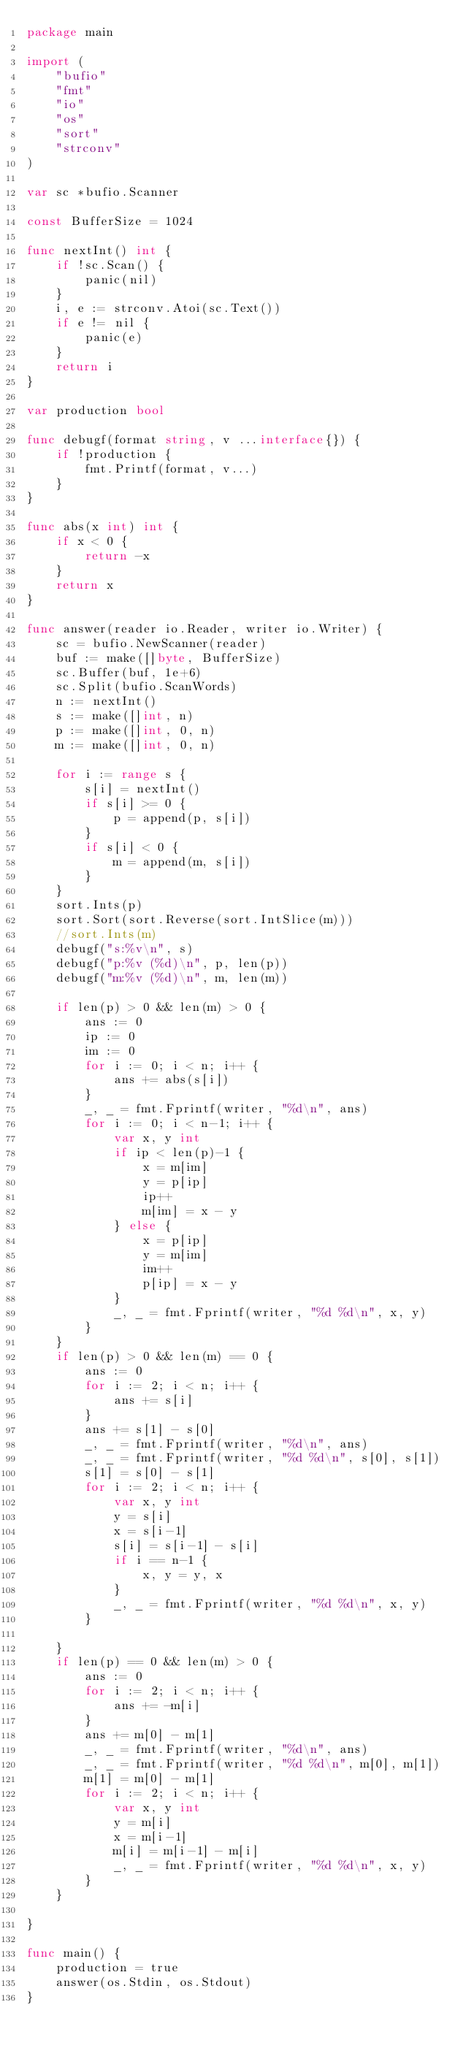<code> <loc_0><loc_0><loc_500><loc_500><_Go_>package main

import (
	"bufio"
	"fmt"
	"io"
	"os"
	"sort"
	"strconv"
)

var sc *bufio.Scanner

const BufferSize = 1024

func nextInt() int {
	if !sc.Scan() {
		panic(nil)
	}
	i, e := strconv.Atoi(sc.Text())
	if e != nil {
		panic(e)
	}
	return i
}

var production bool

func debugf(format string, v ...interface{}) {
	if !production {
		fmt.Printf(format, v...)
	}
}

func abs(x int) int {
	if x < 0 {
		return -x
	}
	return x
}

func answer(reader io.Reader, writer io.Writer) {
	sc = bufio.NewScanner(reader)
	buf := make([]byte, BufferSize)
	sc.Buffer(buf, 1e+6)
	sc.Split(bufio.ScanWords)
	n := nextInt()
	s := make([]int, n)
	p := make([]int, 0, n)
	m := make([]int, 0, n)

	for i := range s {
		s[i] = nextInt()
		if s[i] >= 0 {
			p = append(p, s[i])
		}
		if s[i] < 0 {
			m = append(m, s[i])
		}
	}
	sort.Ints(p)
	sort.Sort(sort.Reverse(sort.IntSlice(m)))
	//sort.Ints(m)
	debugf("s:%v\n", s)
	debugf("p:%v (%d)\n", p, len(p))
	debugf("m:%v (%d)\n", m, len(m))

	if len(p) > 0 && len(m) > 0 {
		ans := 0
		ip := 0
		im := 0
		for i := 0; i < n; i++ {
			ans += abs(s[i])
		}
		_, _ = fmt.Fprintf(writer, "%d\n", ans)
		for i := 0; i < n-1; i++ {
			var x, y int
			if ip < len(p)-1 {
				x = m[im]
				y = p[ip]
				ip++
				m[im] = x - y
			} else {
				x = p[ip]
				y = m[im]
				im++
				p[ip] = x - y
			}
			_, _ = fmt.Fprintf(writer, "%d %d\n", x, y)
		}
	}
	if len(p) > 0 && len(m) == 0 {
		ans := 0
		for i := 2; i < n; i++ {
			ans += s[i]
		}
		ans += s[1] - s[0]
		_, _ = fmt.Fprintf(writer, "%d\n", ans)
		_, _ = fmt.Fprintf(writer, "%d %d\n", s[0], s[1])
		s[1] = s[0] - s[1]
		for i := 2; i < n; i++ {
			var x, y int
			y = s[i]
			x = s[i-1]
			s[i] = s[i-1] - s[i]
			if i == n-1 {
				x, y = y, x
			}
			_, _ = fmt.Fprintf(writer, "%d %d\n", x, y)
		}

	}
	if len(p) == 0 && len(m) > 0 {
		ans := 0
		for i := 2; i < n; i++ {
			ans += -m[i]
		}
		ans += m[0] - m[1]
		_, _ = fmt.Fprintf(writer, "%d\n", ans)
		_, _ = fmt.Fprintf(writer, "%d %d\n", m[0], m[1])
		m[1] = m[0] - m[1]
		for i := 2; i < n; i++ {
			var x, y int
			y = m[i]
			x = m[i-1]
			m[i] = m[i-1] - m[i]
			_, _ = fmt.Fprintf(writer, "%d %d\n", x, y)
		}
	}

}

func main() {
	production = true
	answer(os.Stdin, os.Stdout)
}
</code> 